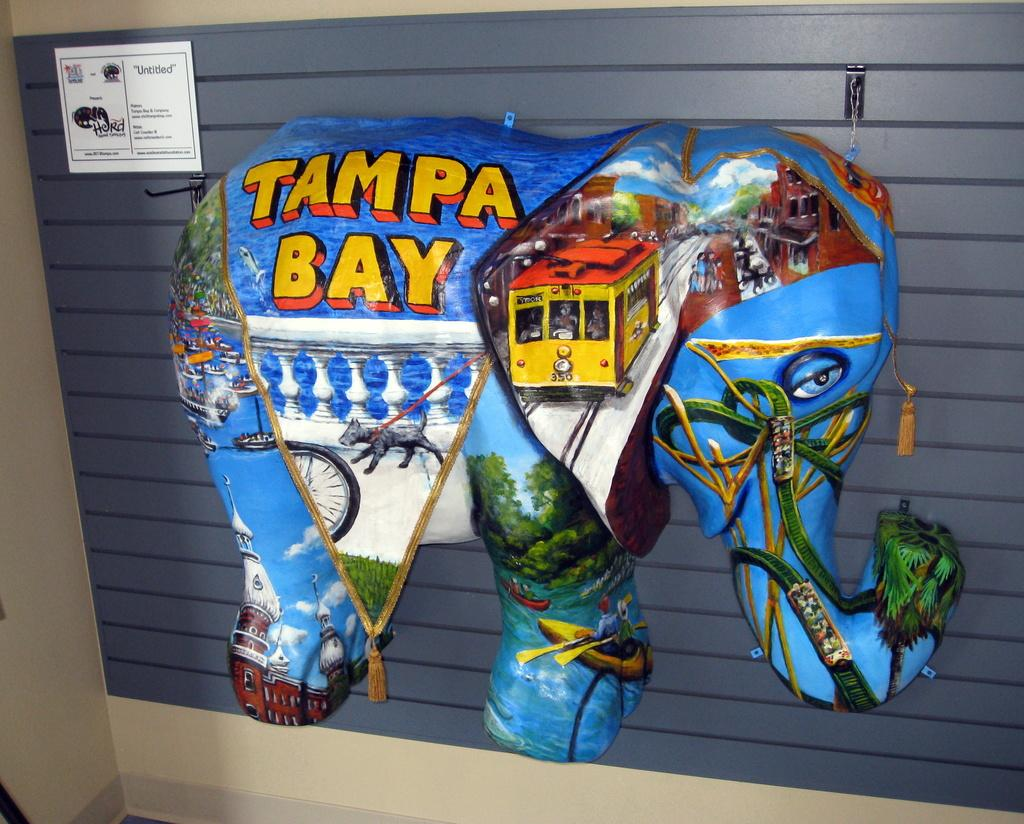What type of toy is present in the image? There is a toy elephant in the image. What can be seen on the toy elephant? The toy elephant has text and painting on it. What else can be seen in the background of the image? There is a card in the background of the image. How does the toy elephant try to get the attention of the viewer in the image? The toy elephant is an inanimate object and cannot actively try to get the attention of the viewer in the image. 